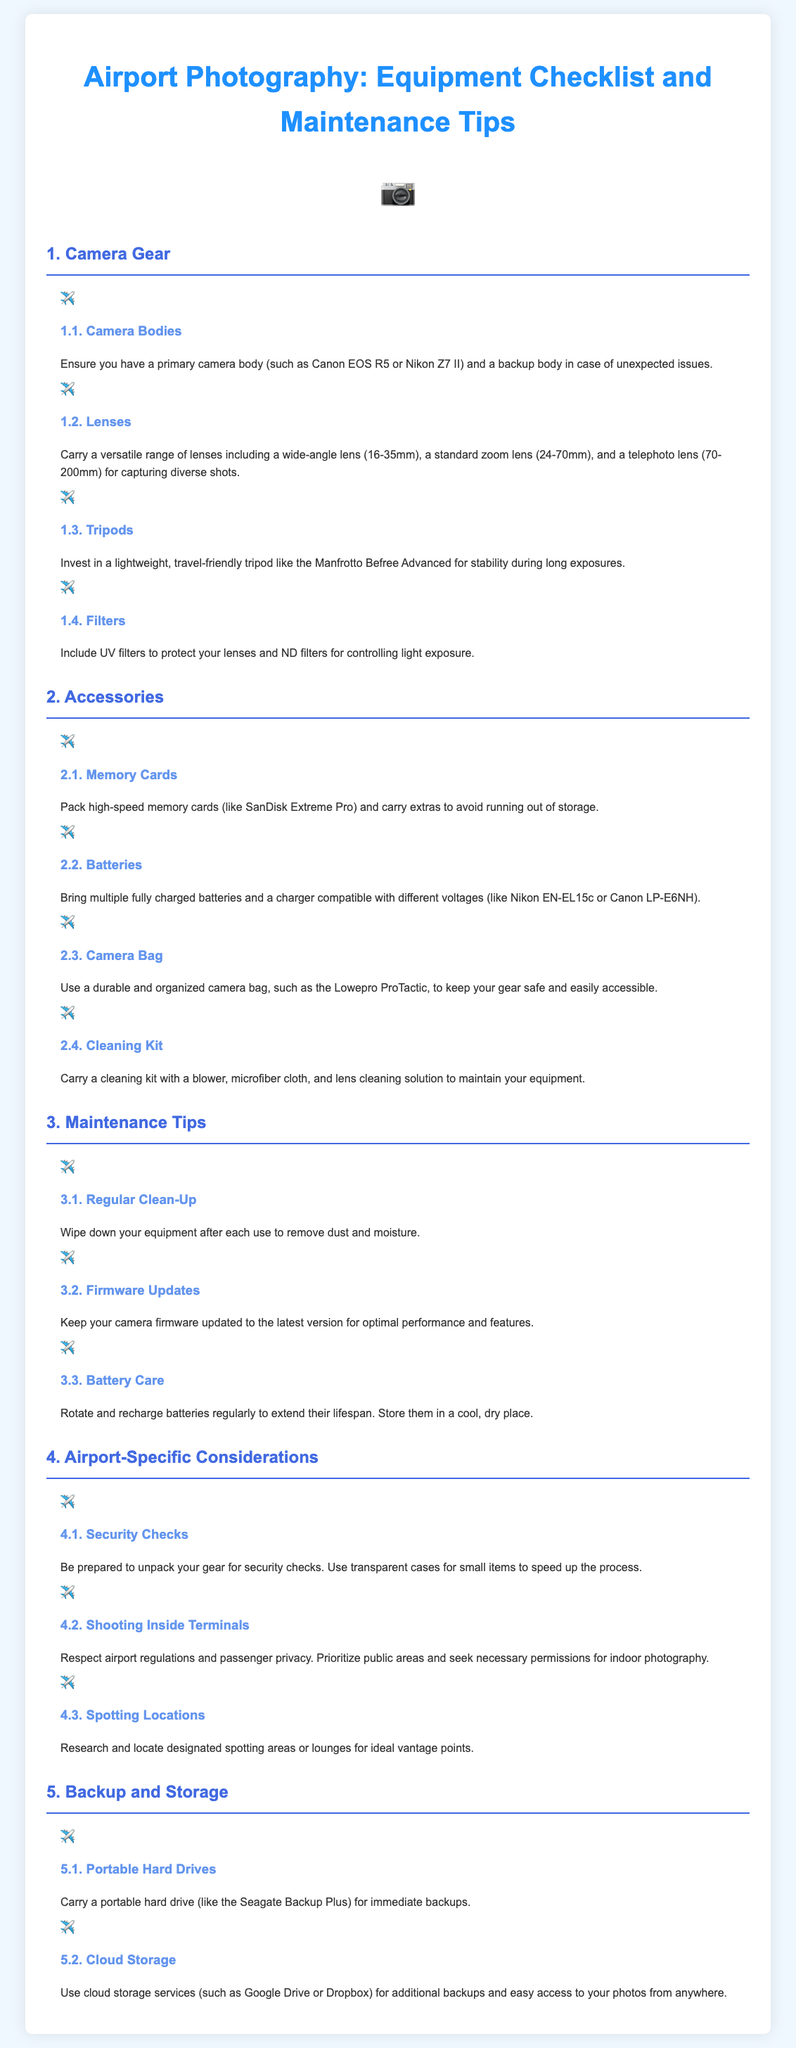what is a recommended lightweight tripod for airport photography? The document suggests investing in a lightweight, travel-friendly tripod and mentions the Manfrotto Befree Advanced specifically.
Answer: Manfrotto Befree Advanced what type of lenses should you carry for diverse shots? The document lists a versatile range of lenses including a wide-angle lens, a standard zoom lens, and a telephoto lens for capturing diverse shots.
Answer: wide-angle, standard zoom, telephoto how many camera bodies should you have when traveling? According to the document, you should have a primary camera body and a backup body in case of unexpected issues.
Answer: two what should you pack to avoid running out of storage? The document advises packing high-speed memory cards and carrying extras to avoid running out of storage.
Answer: memory cards how can you extend battery lifespan according to the tips? The document states that you should rotate and recharge batteries regularly and store them in a cool, dry place to extend their lifespan.
Answer: rotate and recharge what is one of the airport-specific considerations mentioned for shooting inside terminals? The document advises respecting airport regulations and passenger privacy when shooting inside terminals.
Answer: regulations and privacy which type of storage is recommended for immediate backups? The document recommends carrying a portable hard drive for immediate backups.
Answer: portable hard drive what should you do to keep your gear clean after each use? The document suggests wiping down your equipment after each use to remove dust and moisture.
Answer: wipe down equipment 